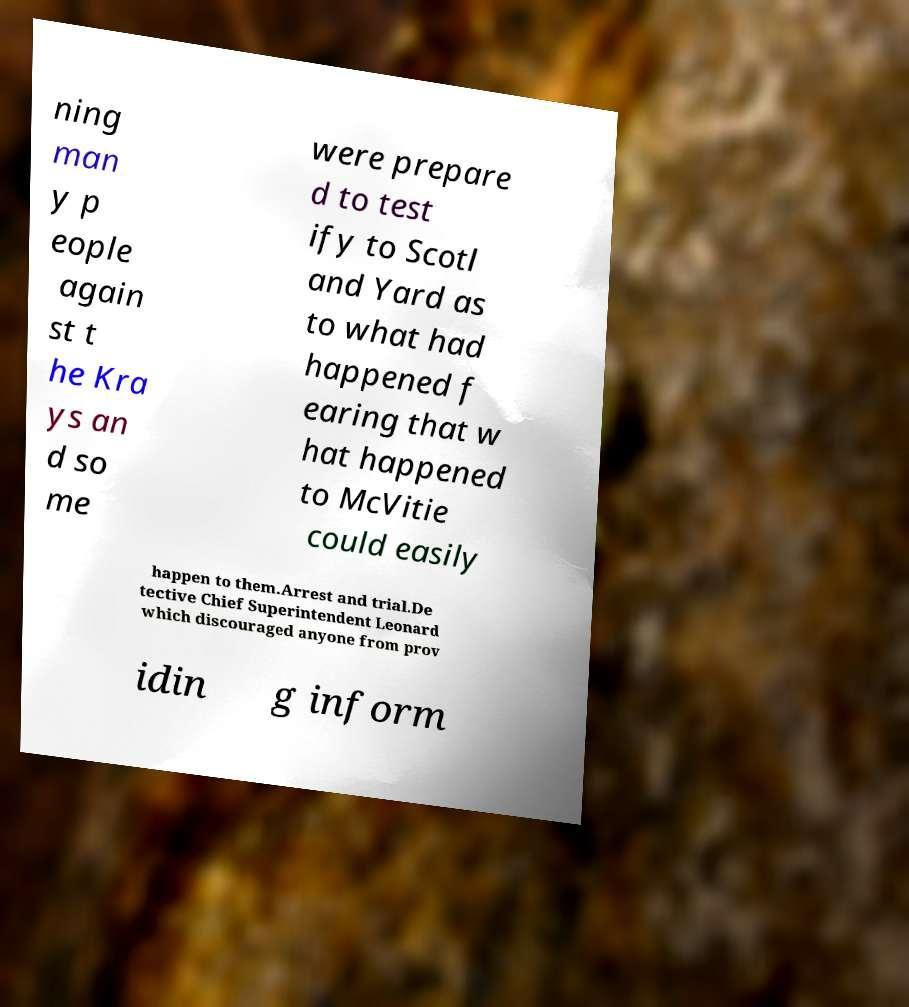Please identify and transcribe the text found in this image. ning man y p eople again st t he Kra ys an d so me were prepare d to test ify to Scotl and Yard as to what had happened f earing that w hat happened to McVitie could easily happen to them.Arrest and trial.De tective Chief Superintendent Leonard which discouraged anyone from prov idin g inform 